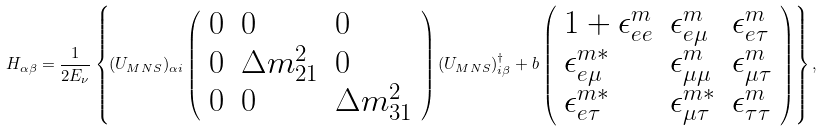Convert formula to latex. <formula><loc_0><loc_0><loc_500><loc_500>H _ { \alpha \beta } = \frac { 1 } { 2 E _ { \nu } } \left \{ ( U _ { M N S } ) _ { \alpha i } \left ( \begin{array} { l l l } 0 & 0 & 0 \\ 0 & \Delta m _ { 2 1 } ^ { 2 } & 0 \\ 0 & 0 & \Delta m _ { 3 1 } ^ { 2 } \end{array} \right ) ( U _ { M N S } ) _ { i \beta } ^ { \dagger } + b \left ( \begin{array} { l l l } 1 + \epsilon _ { e e } ^ { m } & \epsilon _ { e \mu } ^ { m } & \epsilon _ { e \tau } ^ { m } \\ \epsilon _ { e \mu } ^ { m * } & \epsilon _ { \mu \mu } ^ { m } & \epsilon _ { \mu \tau } ^ { m } \\ \epsilon _ { e \tau } ^ { m * } & \epsilon _ { \mu \tau } ^ { m * } & \epsilon _ { \tau \tau } ^ { m } \end{array} \right ) \right \} ,</formula> 